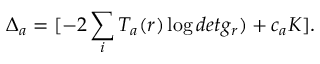<formula> <loc_0><loc_0><loc_500><loc_500>\Delta _ { a } = [ - 2 \sum _ { i } T _ { a } ( r ) \log d e t g _ { r } ) + c _ { a } K ] .</formula> 